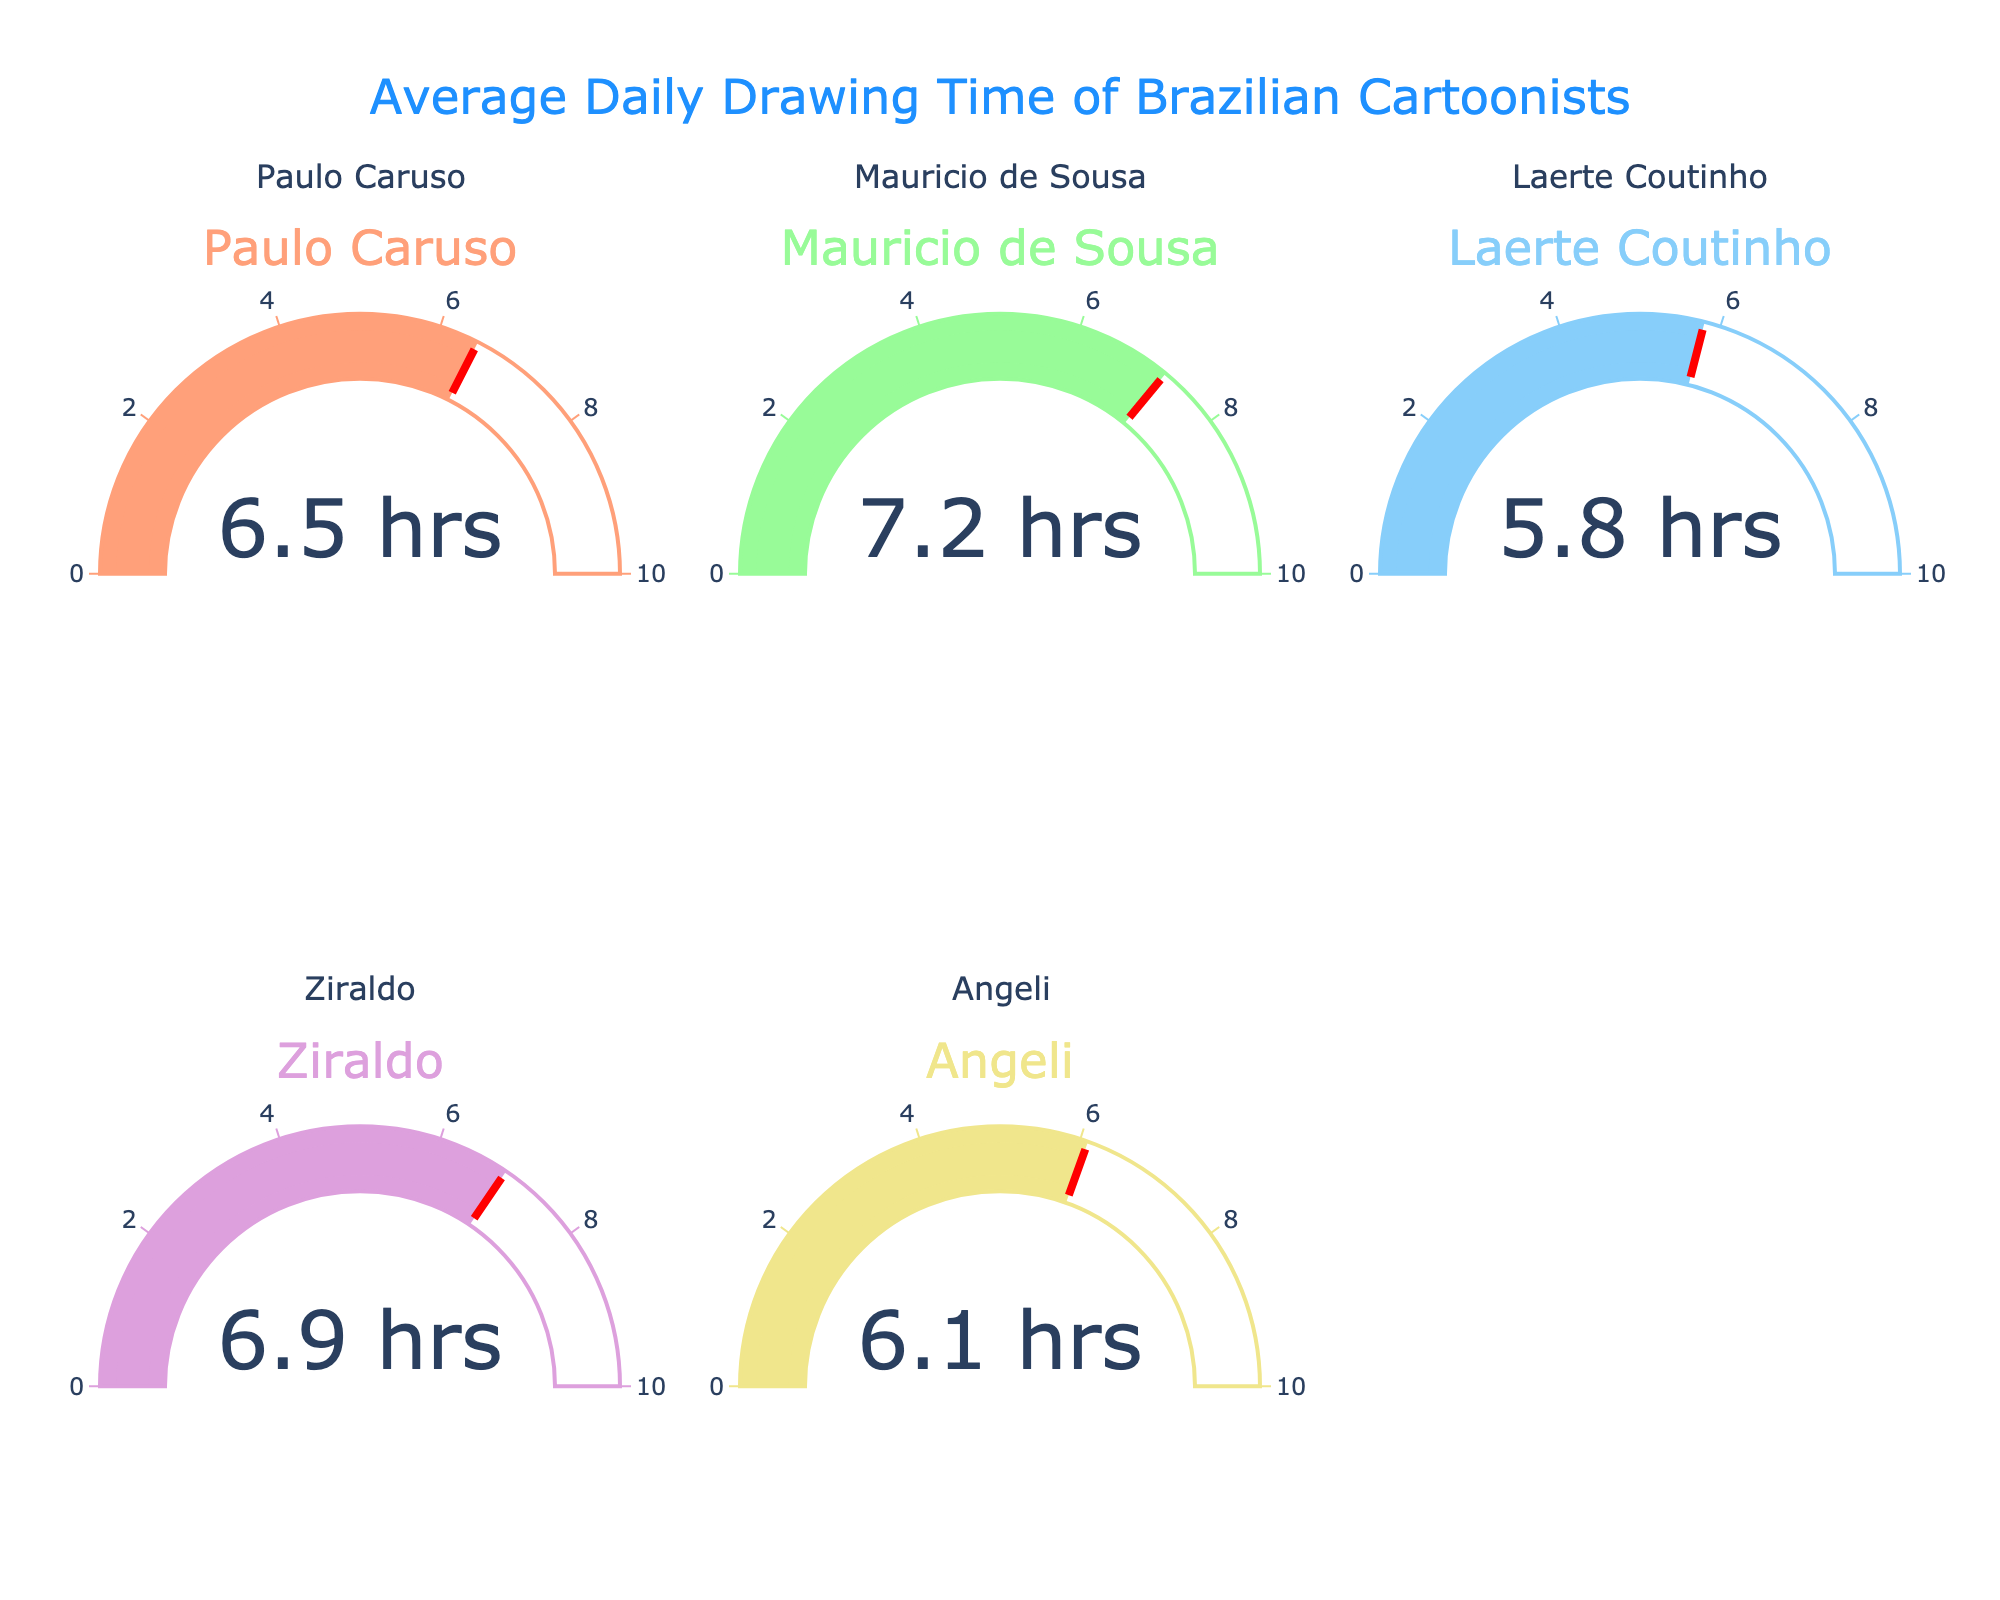What is the average daily drawing time for Paulo Caruso? Look at the gauge chart that represents Paulo Caruso. The value shown is 6.5 hours per day.
Answer: 6.5 hours Which cartoonist spends the most time drawing daily? Compare the values from all gauge charts. Mauricio de Sousa spends 7.2 hours daily, which is the highest.
Answer: Mauricio de Sousa How much more time does Mauricio de Sousa spend drawing daily compared to Laerte Coutinho? The gauge chart shows Mauricio de Sousa with 7.2 hours and Laerte Coutinho with 5.8 hours. The difference is 7.2 - 5.8 = 1.4 hours.
Answer: 1.4 hours What is the total daily drawing time for all the listed cartoonists combined? Add the times: 6.5+7.2+5.8+6.9+6.1. This results in a total of 32.5 hours.
Answer: 32.5 hours Which gauge chart has the lowest value? Compare all the values. Laerte Coutinho has the lowest value with 5.8 hours.
Answer: Laerte Coutinho What is the average daily drawing time for all the cartoonists combined? Calculate the average by summing all the times (32.5 hours) and dividing by the number of cartoonists (5). 32.5 / 5 = 6.5 hours.
Answer: 6.5 hours Which two cartoonists have the most similar daily drawing times? Compare the values to find the closest pair. Paulo Caruso with 6.5 hours and Angeli with 6.1 hours have the smallest difference of 0.4 hours.
Answer: Paulo Caruso and Angeli Is Ziraldo's daily drawing time above or below the average daily drawing time of all cartoonists? The average daily drawing time for all cartoonists is 6.5 hours. Ziraldo's daily drawing time is 6.9 hours, which is above the average.
Answer: Above Which cartoonist’s gauge chart has the most yellow in it? Look at the gauge chart colors; Ziraldo's chart (6.9 hours) has the most yellow as the yellow range exceeds others.
Answer: Ziraldo 